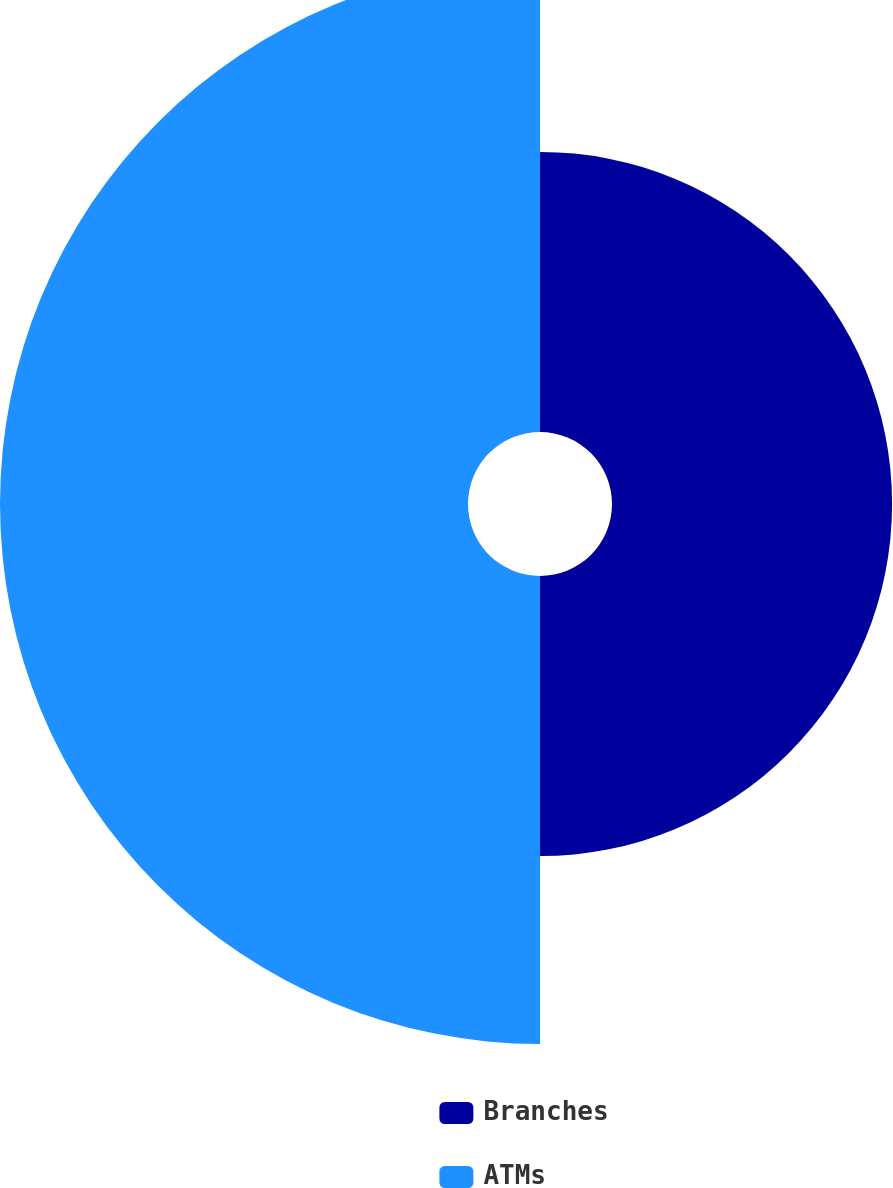<chart> <loc_0><loc_0><loc_500><loc_500><pie_chart><fcel>Branches<fcel>ATMs<nl><fcel>37.44%<fcel>62.56%<nl></chart> 